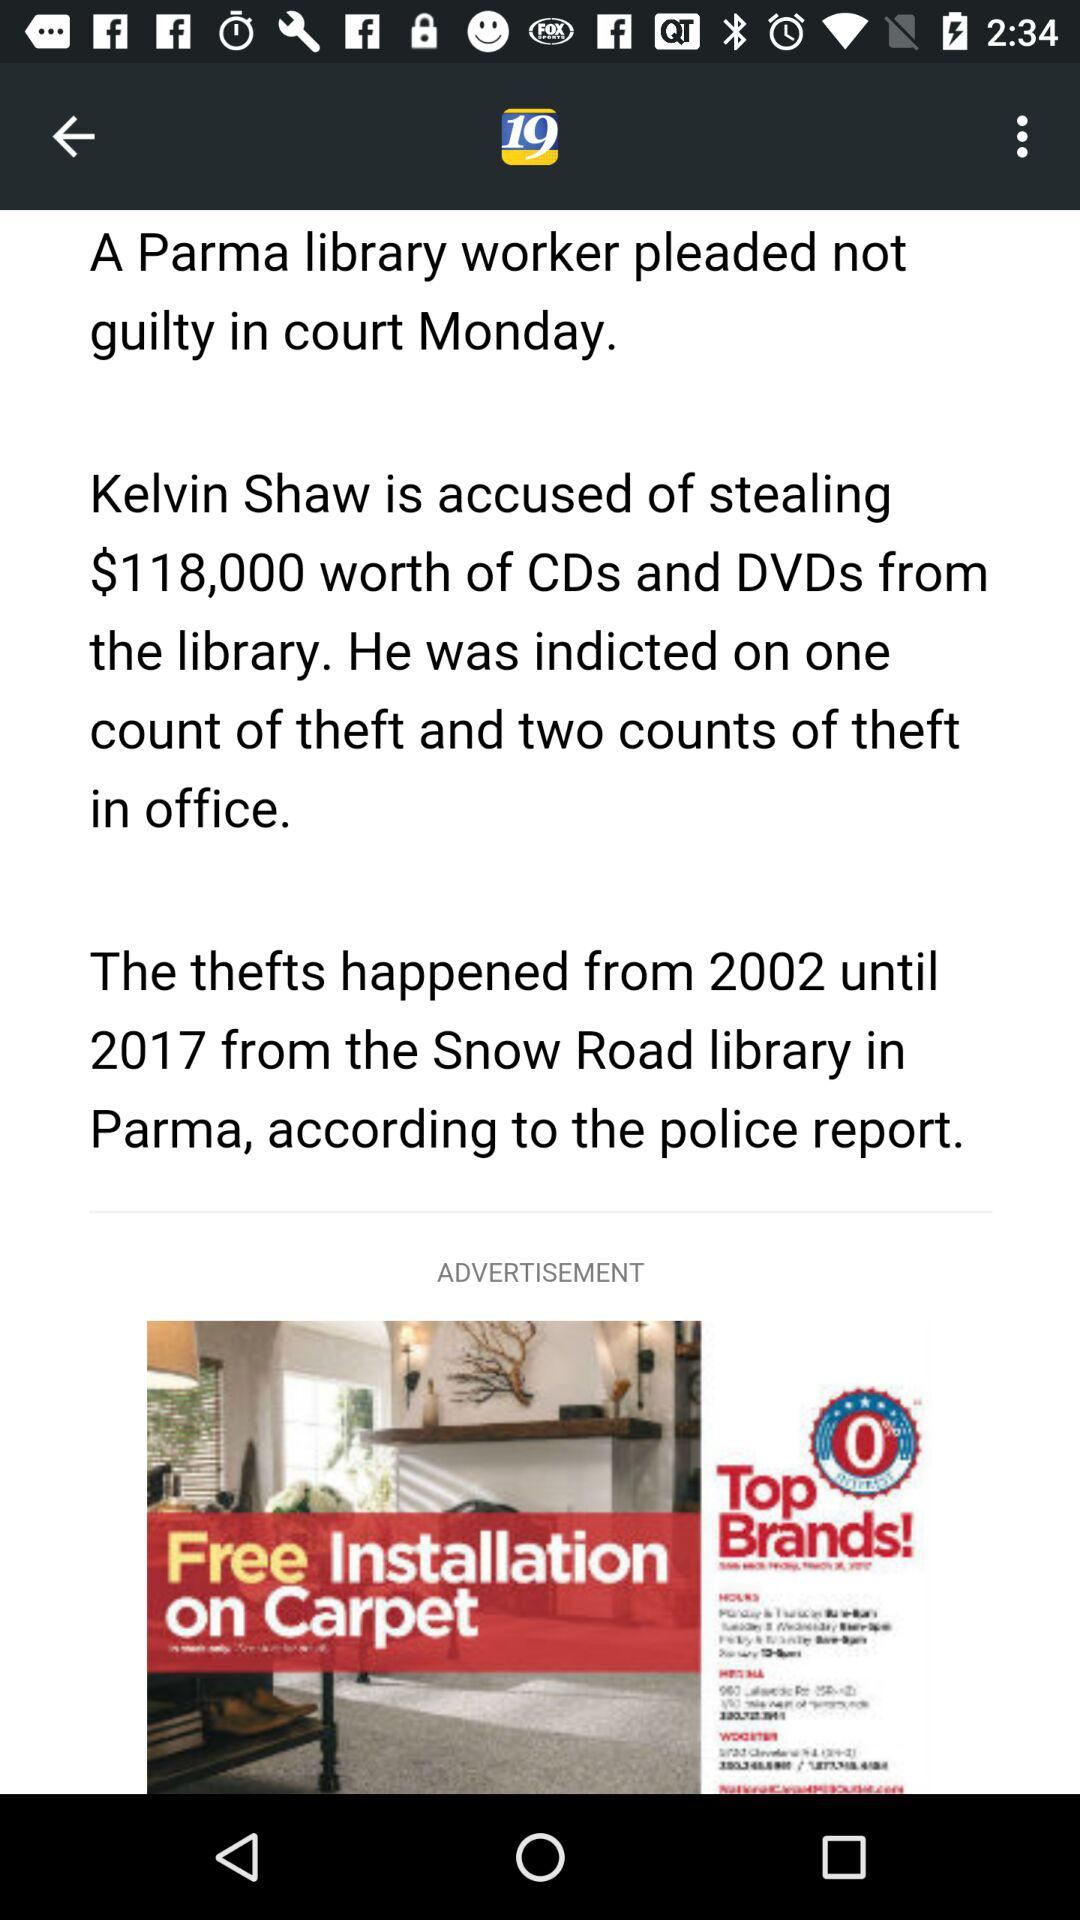How many counts of theft is Kelvin Shaw accused of?
Answer the question using a single word or phrase. 3 